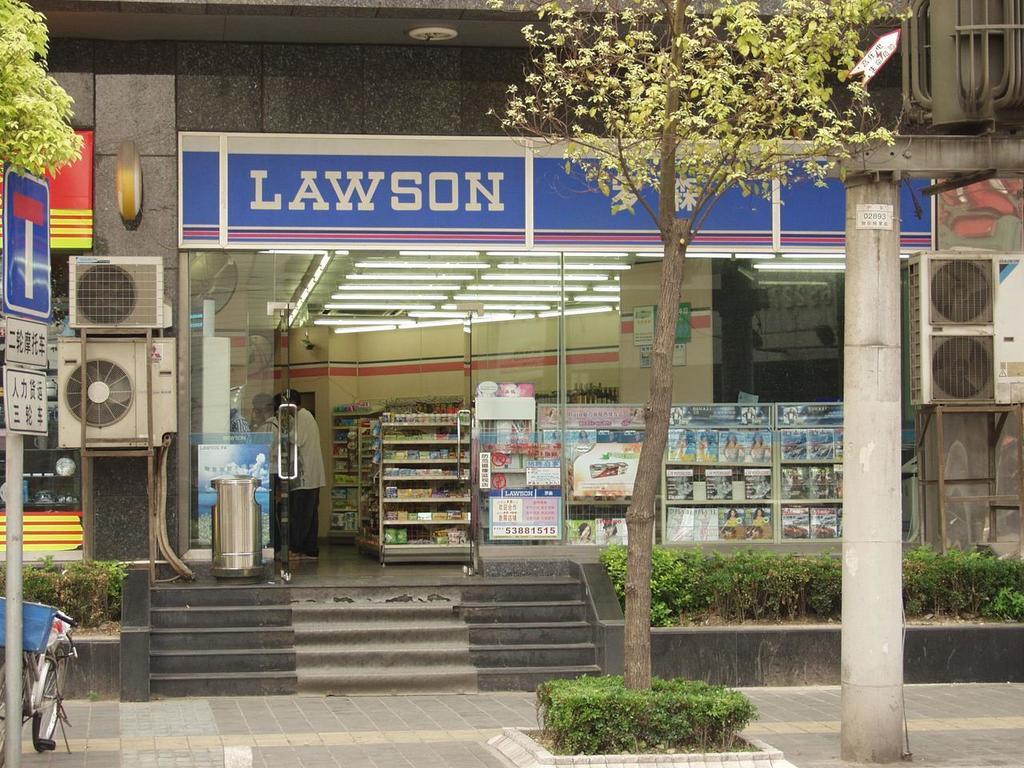What is the name of this store?
Provide a succinct answer. Lawson. 